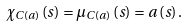Convert formula to latex. <formula><loc_0><loc_0><loc_500><loc_500>\chi _ { C \left ( a \right ) } \left ( s \right ) = \mu _ { C \left ( a \right ) } \left ( s \right ) = a \left ( s \right ) .</formula> 